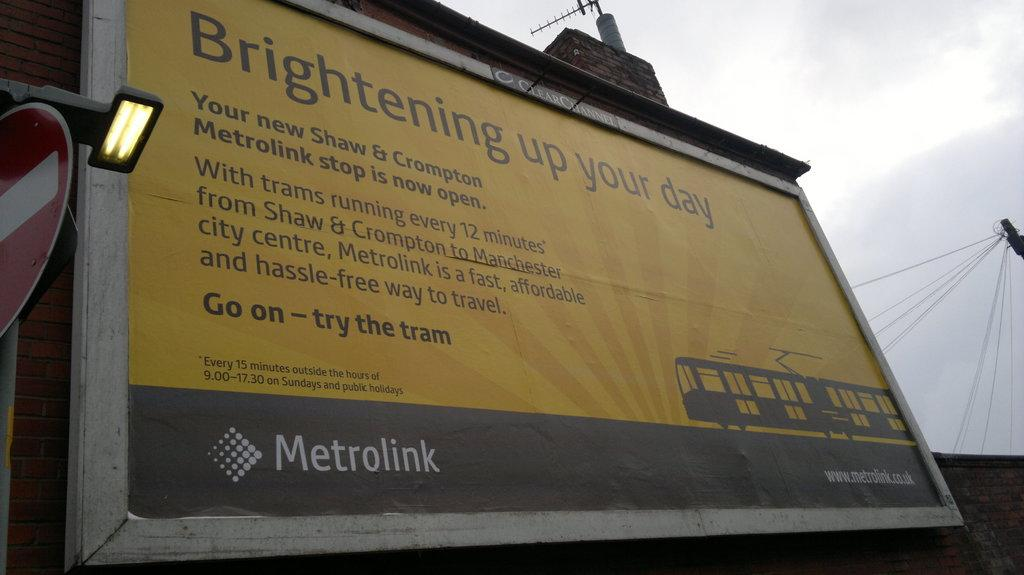<image>
Share a concise interpretation of the image provided. A big poster explaining how Metrolink will brighten your day on a cloudy day. 